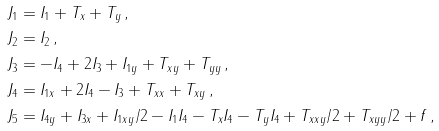<formula> <loc_0><loc_0><loc_500><loc_500>J _ { 1 } & = I _ { 1 } + T _ { x } + T _ { y } \, , \\ J _ { 2 } & = I _ { 2 } \, , \\ J _ { 3 } & = - I _ { 4 } + 2 I _ { 3 } + I _ { 1 y } + T _ { x y } + T _ { y y } \, , \\ J _ { 4 } & = I _ { 1 x } + 2 I _ { 4 } - I _ { 3 } + T _ { x x } + T _ { x y } \, , \\ J _ { 5 } & = I _ { 4 y } + I _ { 3 x } + I _ { 1 x y } / 2 - I _ { 1 } I _ { 4 } - T _ { x } I _ { 4 } - T _ { y } I _ { 4 } + T _ { x x y } / 2 + T _ { x y y } / 2 + f \, ,</formula> 